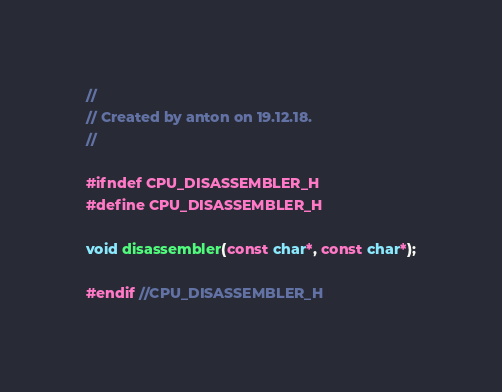Convert code to text. <code><loc_0><loc_0><loc_500><loc_500><_C_>//
// Created by anton on 19.12.18.
//

#ifndef CPU_DISASSEMBLER_H
#define CPU_DISASSEMBLER_H

void disassembler(const char*, const char*);

#endif //CPU_DISASSEMBLER_H
</code> 